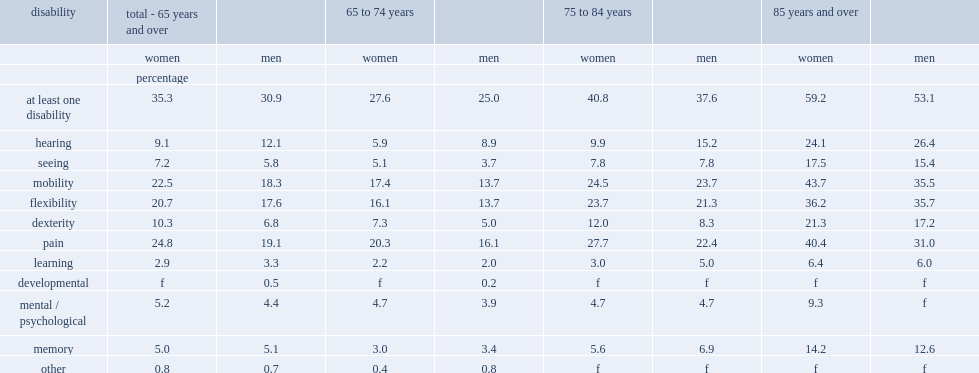What's the percentage of women aged 65 and over living in private households reported having at least one disability. 35.3. What's the percentage of women aged 85 and over reported having at least one disability. 59.2. Which is less likely to report having a disability,men aged 65 or women aged 65. Men. 